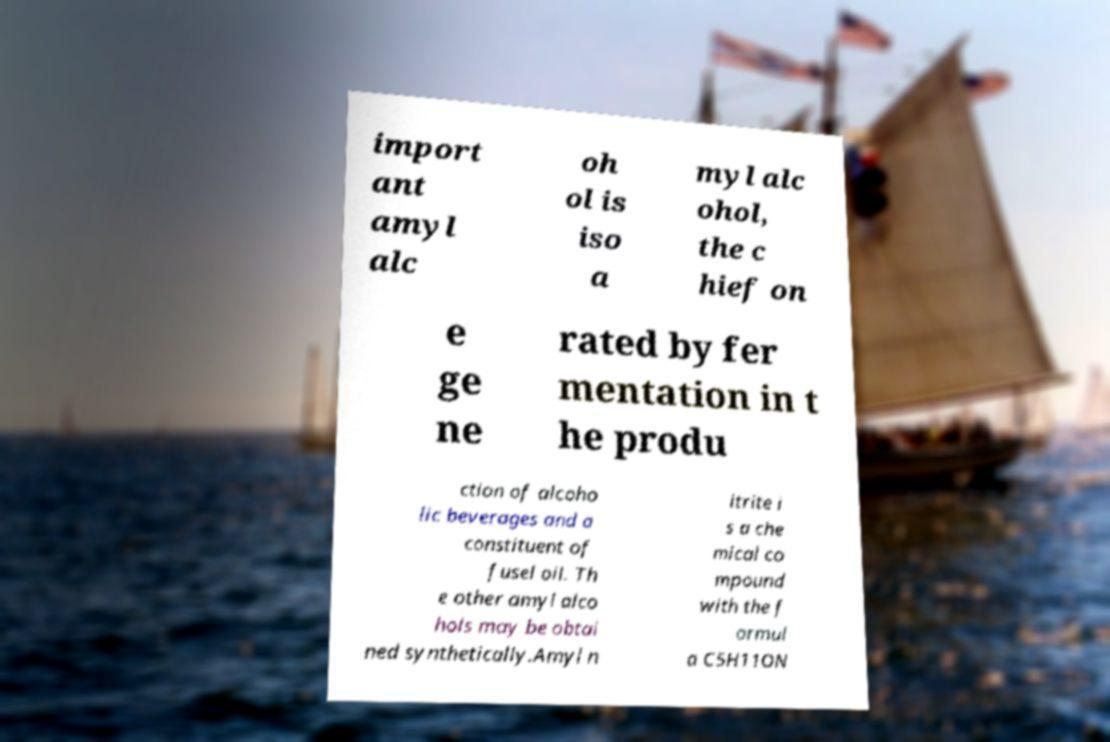Could you assist in decoding the text presented in this image and type it out clearly? import ant amyl alc oh ol is iso a myl alc ohol, the c hief on e ge ne rated by fer mentation in t he produ ction of alcoho lic beverages and a constituent of fusel oil. Th e other amyl alco hols may be obtai ned synthetically.Amyl n itrite i s a che mical co mpound with the f ormul a C5H11ON 